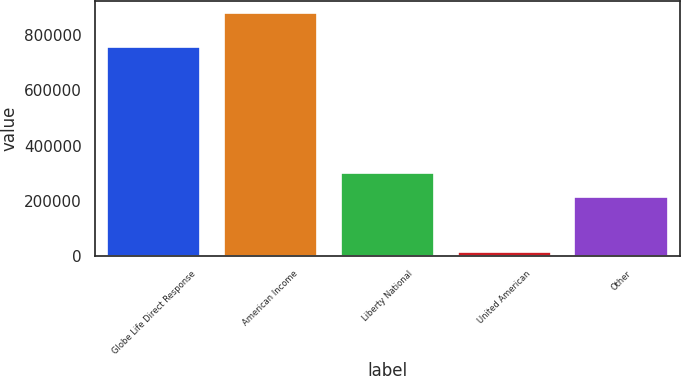Convert chart. <chart><loc_0><loc_0><loc_500><loc_500><bar_chart><fcel>Globe Life Direct Response<fcel>American Income<fcel>Liberty National<fcel>United American<fcel>Other<nl><fcel>757518<fcel>880021<fcel>300427<fcel>14488<fcel>213874<nl></chart> 